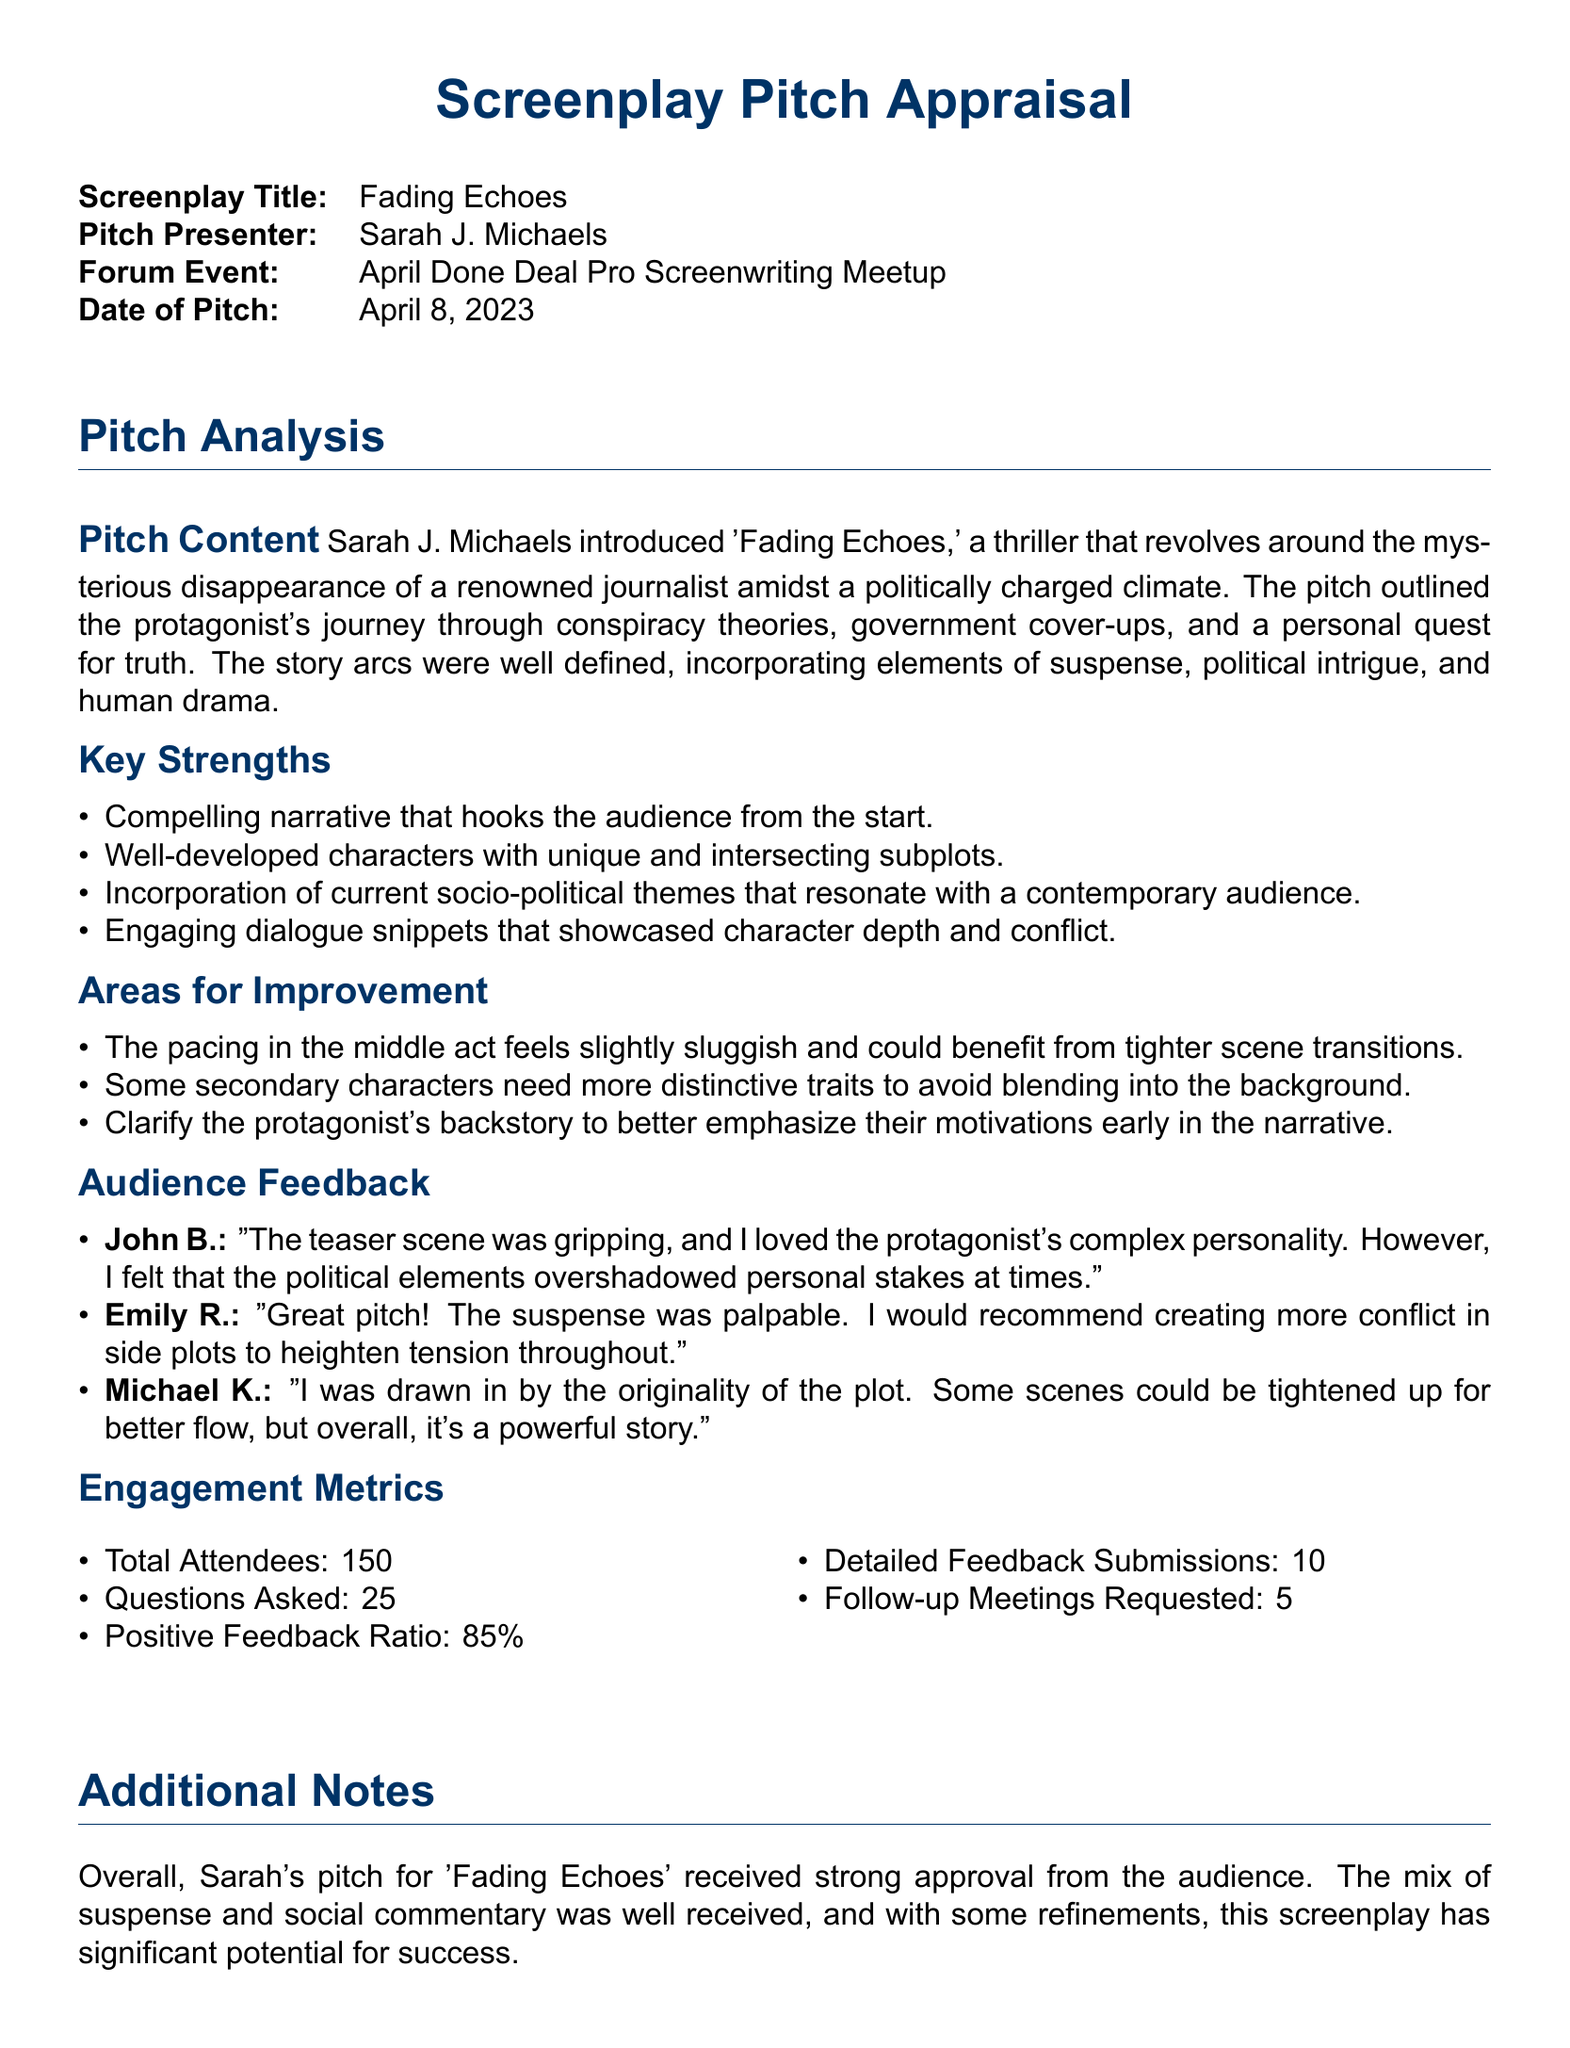what is the title of the screenplay? The title of the screenplay is mentioned at the beginning of the document.
Answer: Fading Echoes who is the pitch presenter? The document states the name of the person who presented the pitch.
Answer: Sarah J. Michaels when did the pitch presentation occur? The document provides the specific date of the pitch presentation.
Answer: April 8, 2023 what is the positive feedback ratio? The document includes a statistic about the positive feedback received from the audience.
Answer: 85% who expressed concerns about the political elements in the screenplay? The document notes a specific individual's feedback regarding the political aspects of the story.
Answer: John B what is one area for improvement mentioned? The document lists potential weaknesses in the pitch that could be addressed.
Answer: Pacing in the middle act how many follow-up meetings were requested? The document provides a specific count of how many follow-up meetings the presenter received interest for.
Answer: 5 what was the total number of attendees at the event? The document states how many people were present during the pitch.
Answer: 150 which character's personality was highlighted as complex in the feedback? The audience feedback specifically mentions a characteristic of the main character in their comments.
Answer: Protagonist 